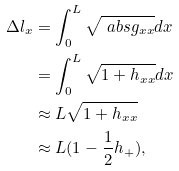Convert formula to latex. <formula><loc_0><loc_0><loc_500><loc_500>\Delta l _ { x } & = \int _ { 0 } ^ { L } \sqrt { \ a b s { g _ { x x } } } d x \\ & = \int _ { 0 } ^ { L } \sqrt { 1 + h _ { x x } } d x \\ & \approx L \sqrt { 1 + h _ { x x } } \\ & \approx L ( 1 - \frac { 1 } { 2 } h _ { + } ) ,</formula> 